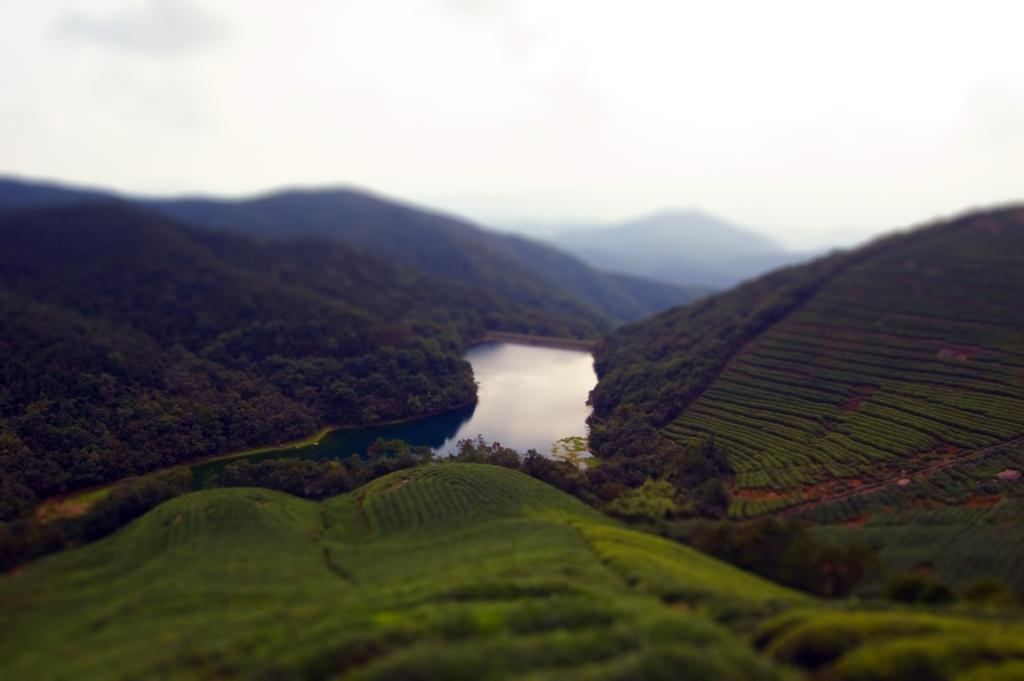What is there is a natural element present in the image, what is it? There is water in the image. What other natural elements can be seen in the image? There are trees and hills visible in the image. What is visible in the background of the image? Hills are visible in the background of the image. What is visible above the image? The sky is visible in the image. What can be observed in the sky? Clouds are present in the sky. What is the purpose of the earthquake in the image? There is no earthquake present in the image. What is the way the trees are arranged in the image? The trees are not arranged in any particular way in the image; they are simply visible. 